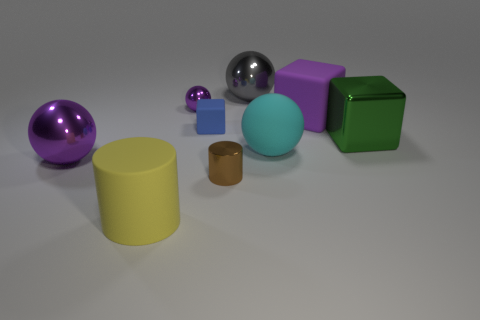Subtract all large purple balls. How many balls are left? 3 Add 1 blue cubes. How many objects exist? 10 Subtract all blue cubes. How many cubes are left? 2 Subtract all balls. How many objects are left? 5 Subtract 2 cubes. How many cubes are left? 1 Subtract all brown cylinders. Subtract all red cubes. How many cylinders are left? 1 Subtract all red spheres. How many blue cylinders are left? 0 Subtract all cylinders. Subtract all small blue matte blocks. How many objects are left? 6 Add 1 green metallic things. How many green metallic things are left? 2 Add 8 tiny purple balls. How many tiny purple balls exist? 9 